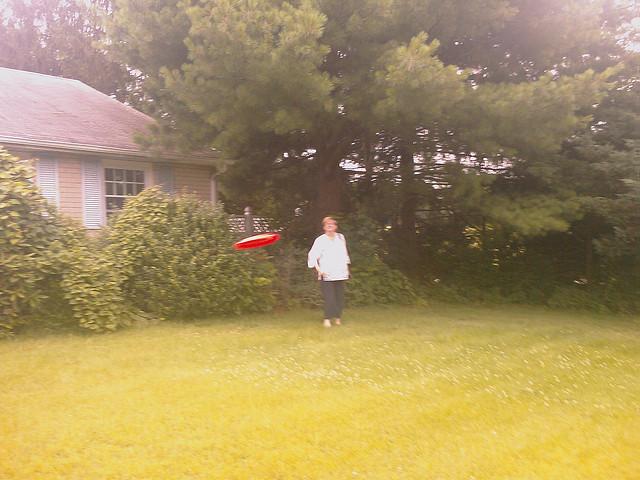What color is the frisbee?
Write a very short answer. Red. What color is the woman's shirt?
Write a very short answer. White. Is the woman outside?
Be succinct. Yes. 